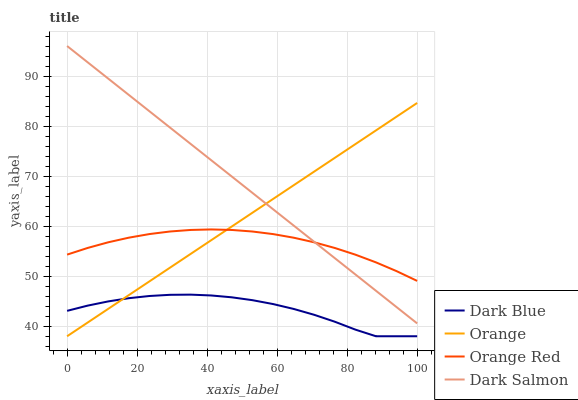Does Dark Blue have the minimum area under the curve?
Answer yes or no. Yes. Does Dark Salmon have the maximum area under the curve?
Answer yes or no. Yes. Does Orange Red have the minimum area under the curve?
Answer yes or no. No. Does Orange Red have the maximum area under the curve?
Answer yes or no. No. Is Orange the smoothest?
Answer yes or no. Yes. Is Dark Blue the roughest?
Answer yes or no. Yes. Is Orange Red the smoothest?
Answer yes or no. No. Is Orange Red the roughest?
Answer yes or no. No. Does Orange have the lowest value?
Answer yes or no. Yes. Does Orange Red have the lowest value?
Answer yes or no. No. Does Dark Salmon have the highest value?
Answer yes or no. Yes. Does Orange Red have the highest value?
Answer yes or no. No. Is Dark Blue less than Dark Salmon?
Answer yes or no. Yes. Is Orange Red greater than Dark Blue?
Answer yes or no. Yes. Does Orange intersect Dark Blue?
Answer yes or no. Yes. Is Orange less than Dark Blue?
Answer yes or no. No. Is Orange greater than Dark Blue?
Answer yes or no. No. Does Dark Blue intersect Dark Salmon?
Answer yes or no. No. 